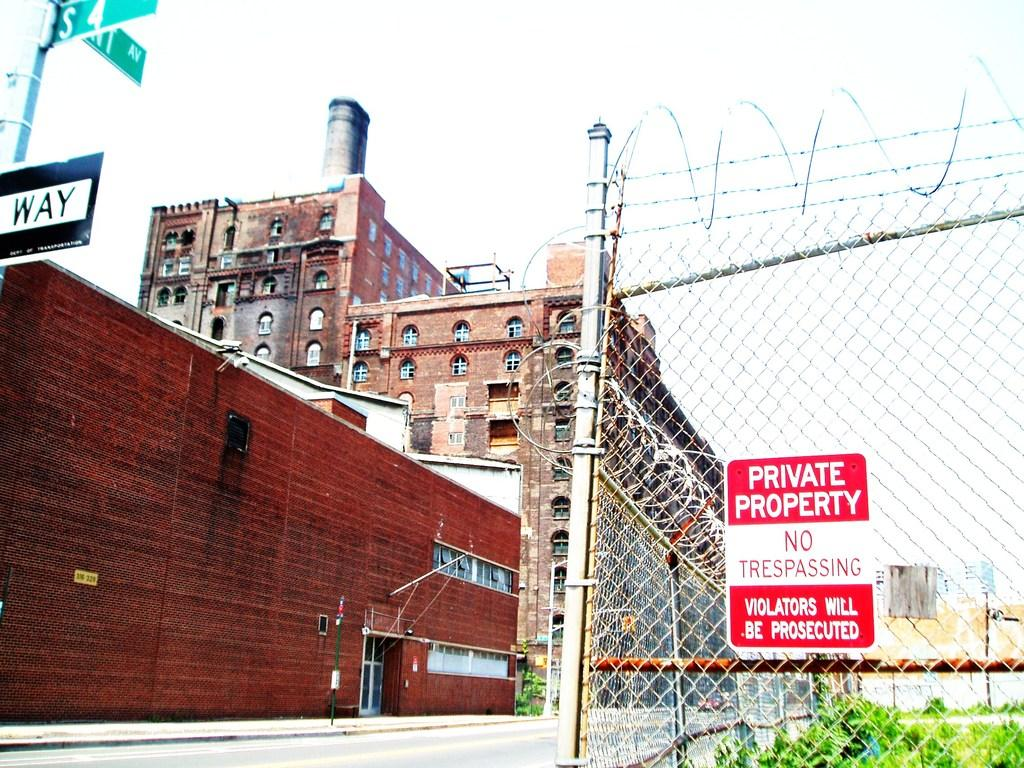What is the main feature of the image? There are many buildings in the image. Can you describe any specific details about the buildings? Unfortunately, the provided facts do not mention any specific details about the buildings. What is located on the right side of the image? There is a sign board on the fencing on the right side of the image. What else can be seen at the bottom of the image? There is a plant visible at the bottom of the image. What is visible at the top of the image? The sky is visible at the top of the image. What type of plant does the goose prefer to eat in the image? There is no goose present in the image, so it is not possible to determine what type of plant it might prefer to eat. 